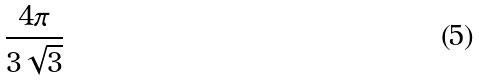<formula> <loc_0><loc_0><loc_500><loc_500>\frac { 4 \pi } { 3 \sqrt { 3 } }</formula> 